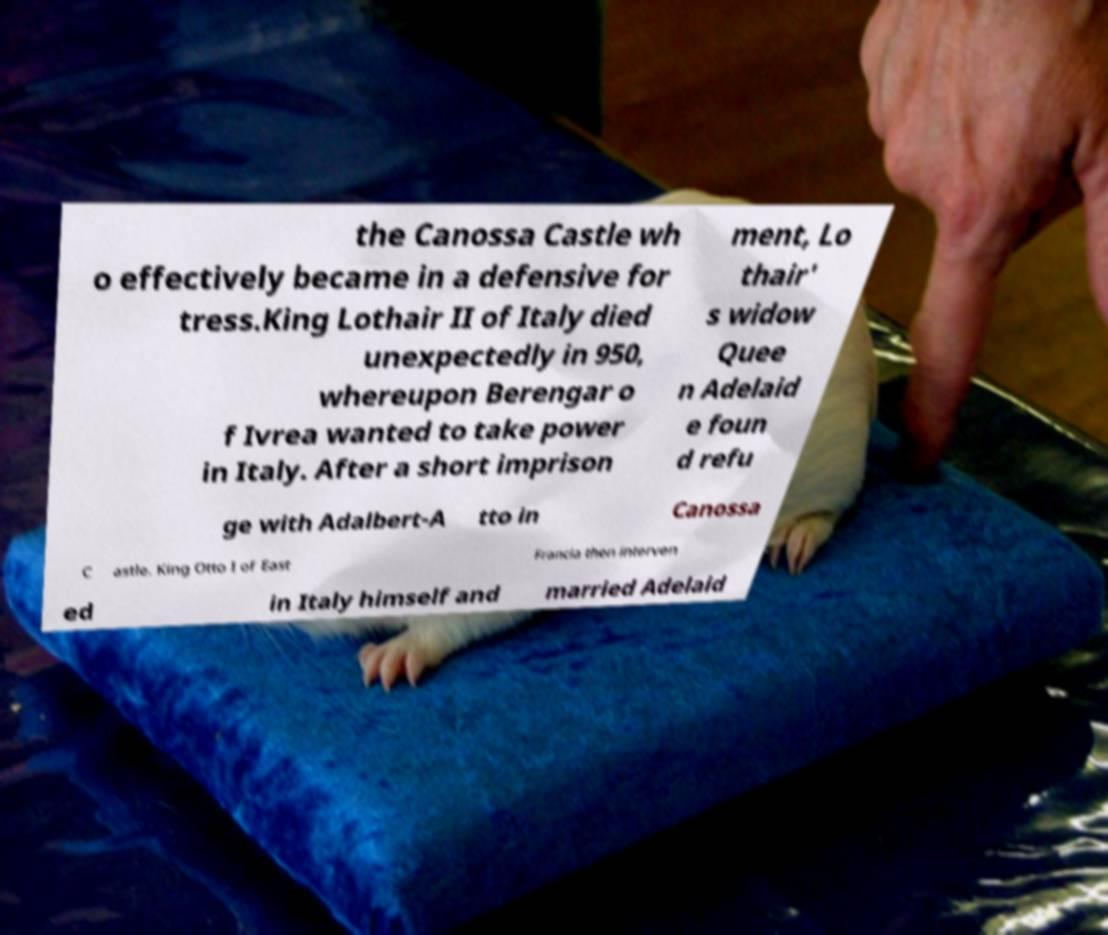Could you extract and type out the text from this image? the Canossa Castle wh o effectively became in a defensive for tress.King Lothair II of Italy died unexpectedly in 950, whereupon Berengar o f Ivrea wanted to take power in Italy. After a short imprison ment, Lo thair' s widow Quee n Adelaid e foun d refu ge with Adalbert-A tto in Canossa C astle. King Otto I of East Francia then interven ed in Italy himself and married Adelaid 